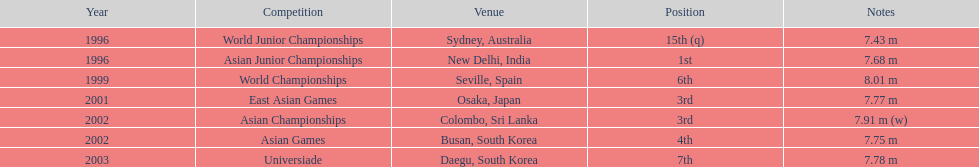Which competition did this person compete in immediately before the east asian games in 2001? World Championships. 